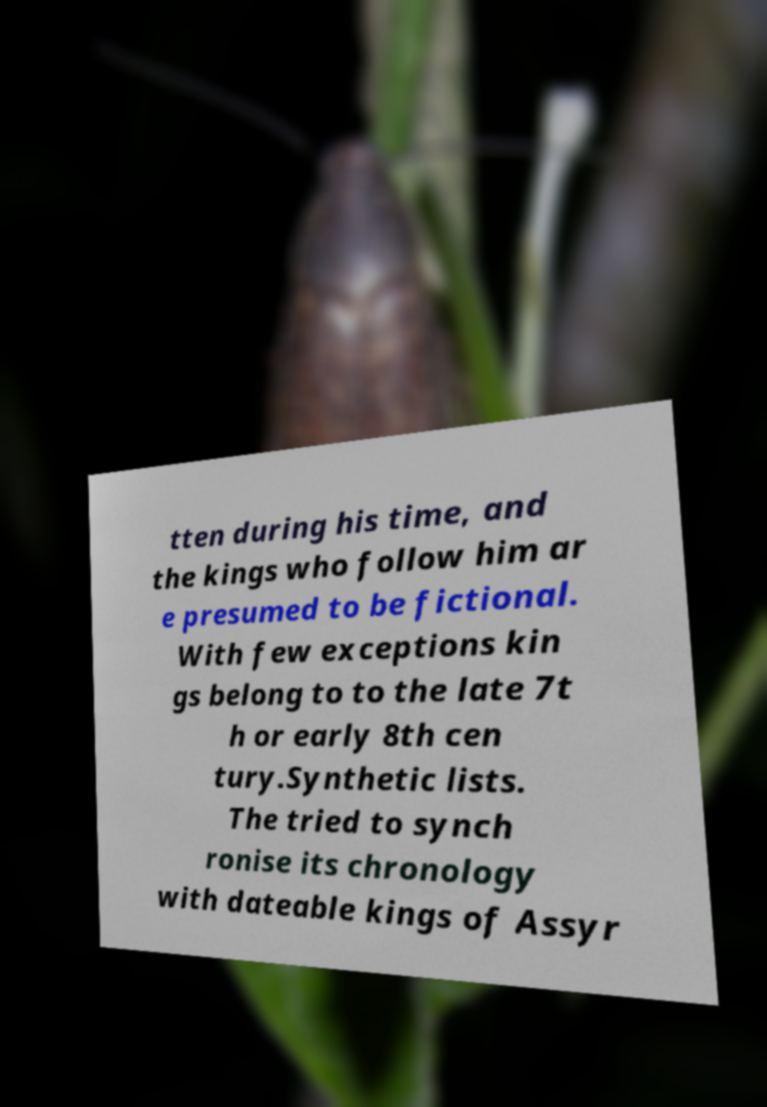For documentation purposes, I need the text within this image transcribed. Could you provide that? tten during his time, and the kings who follow him ar e presumed to be fictional. With few exceptions kin gs belong to to the late 7t h or early 8th cen tury.Synthetic lists. The tried to synch ronise its chronology with dateable kings of Assyr 